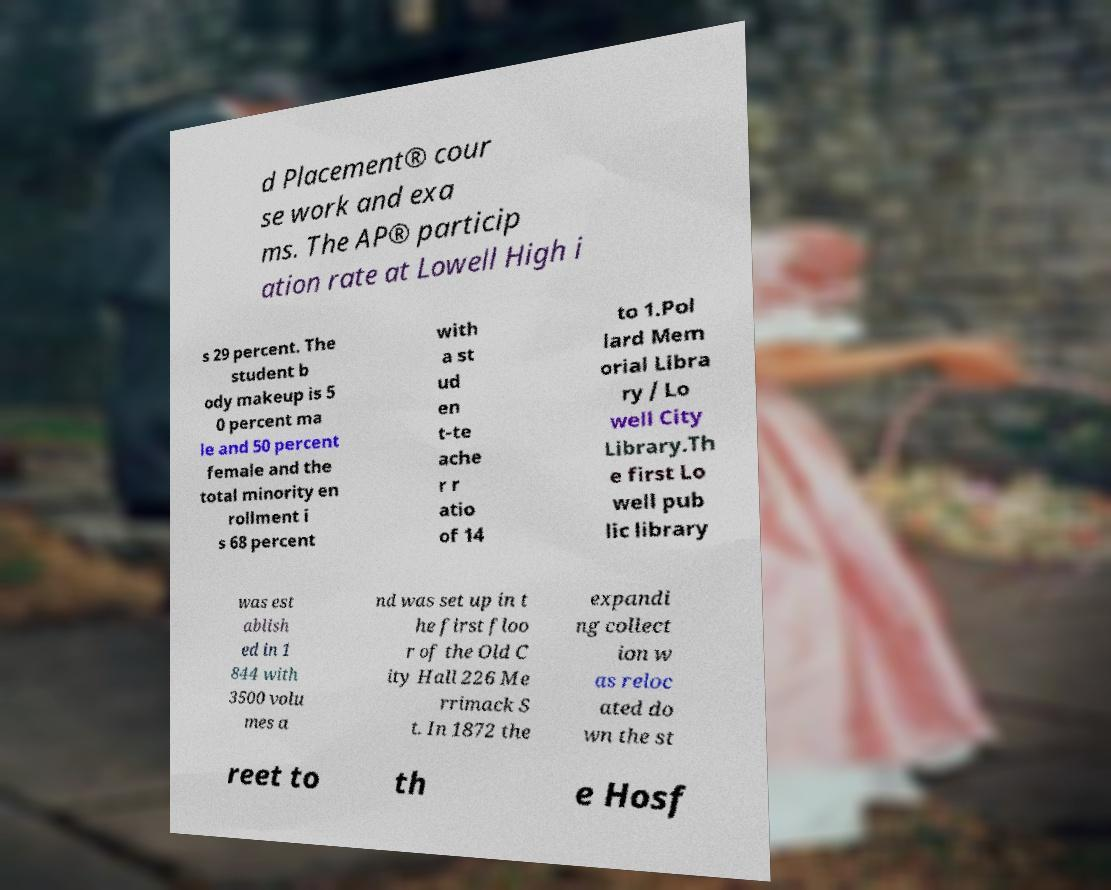I need the written content from this picture converted into text. Can you do that? d Placement® cour se work and exa ms. The AP® particip ation rate at Lowell High i s 29 percent. The student b ody makeup is 5 0 percent ma le and 50 percent female and the total minority en rollment i s 68 percent with a st ud en t-te ache r r atio of 14 to 1.Pol lard Mem orial Libra ry / Lo well City Library.Th e first Lo well pub lic library was est ablish ed in 1 844 with 3500 volu mes a nd was set up in t he first floo r of the Old C ity Hall 226 Me rrimack S t. In 1872 the expandi ng collect ion w as reloc ated do wn the st reet to th e Hosf 